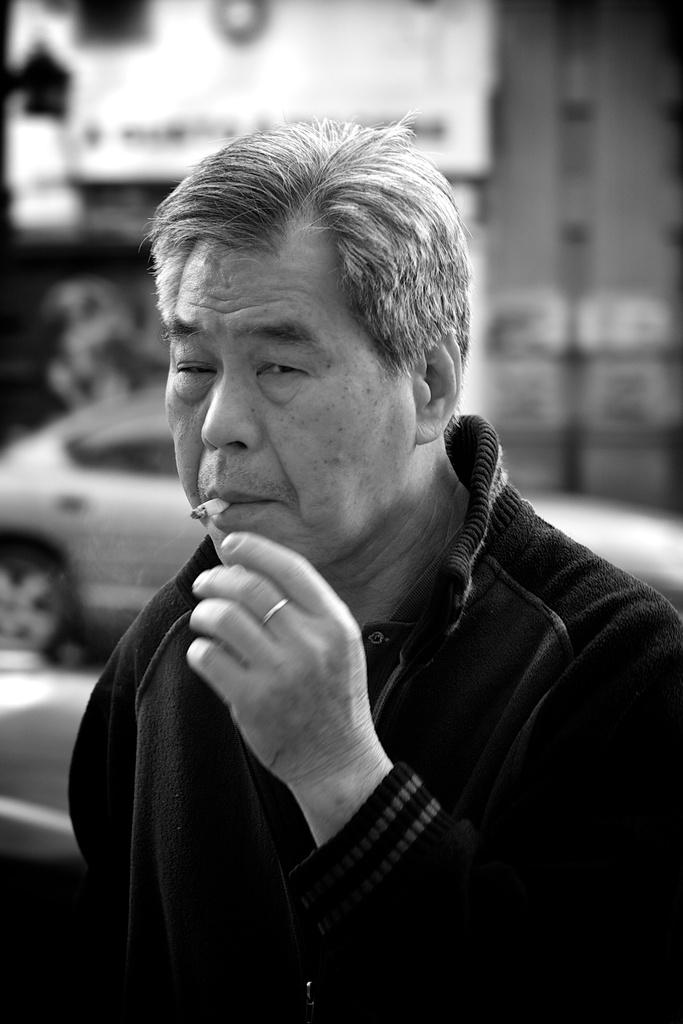What is present in the image? There is a person in the image. What is the person wearing? The person is wearing a jacket. What is the person doing with their mouth? The person has a cigarette in their mouth. What is the person doing with the cigarette? The person is smoking. What can be seen in the background of the image? There is a vehicle in the background of the image. How is the background of the image depicted? The background is blurred. What type of bird is sitting on the jar in the image? There is no bird or jar present in the image. 